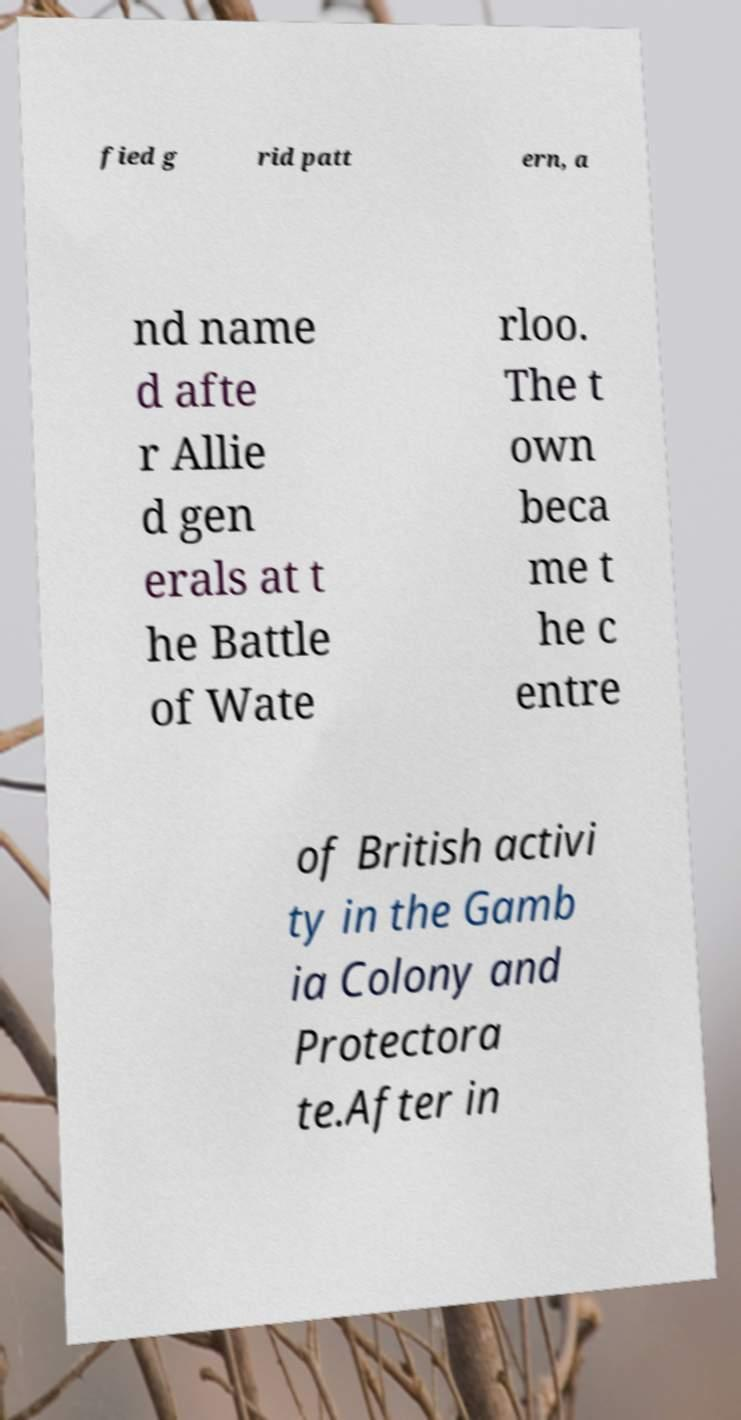Could you extract and type out the text from this image? fied g rid patt ern, a nd name d afte r Allie d gen erals at t he Battle of Wate rloo. The t own beca me t he c entre of British activi ty in the Gamb ia Colony and Protectora te.After in 